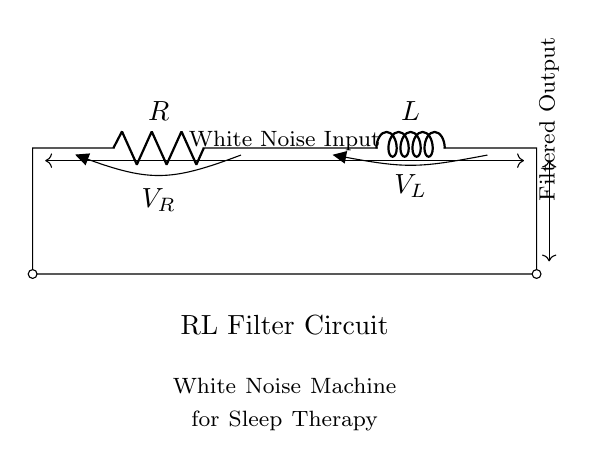What are the components in this circuit? The components shown are a resistor labeled R and an inductor labeled L. These are the key elements of the RL filter circuit and are essential for its function.
Answer: Resistor and Inductor What is the purpose of the circuit diagram? The circuit diagram is used to create a white noise machine for sleep therapy. The RL filter allows specific frequencies to be filtered while creating a soothing sound environment conducive to sleep.
Answer: White noise machine for sleep therapy What type of filter is represented by this circuit? The RL circuit is specifically a low-pass filter, which allows low-frequency signals to pass while attenuating higher frequencies, which is useful for filtering out unwanted noise in audio applications.
Answer: Low-pass filter What is the input and output labeled in the circuit? The circuit indicates that the input is white noise, which is applied at one end, and the filtered output is taken from the other end after passing through the circuit. This shows the transformation from input to output.
Answer: White Noise Input and Filtered Output What happens to high-frequency noise in this circuit? The high-frequency noise is significantly reduced due to the filtering action of the inductor and resistor combination, which impedes the flow of these frequencies while allowing lower frequencies to pass through.
Answer: Reduced What is the voltage across the resistor called? The voltage across the resistor is labeled as V_R in the circuit diagram, and this represents the potential difference across the resistor component as current flows through it.
Answer: V_R What is the overall effect of using an RL filter in a white noise machine? The RL filter smooths out abrupt variations by reducing high-frequency noise, creating a steadier output that is perceived as calming sound waves, thereby improving the effectiveness of the white noise for sleep therapy.
Answer: Smoother sound output 